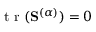Convert formula to latex. <formula><loc_0><loc_0><loc_500><loc_500>t r ( S ^ { ( \alpha ) } ) = 0</formula> 